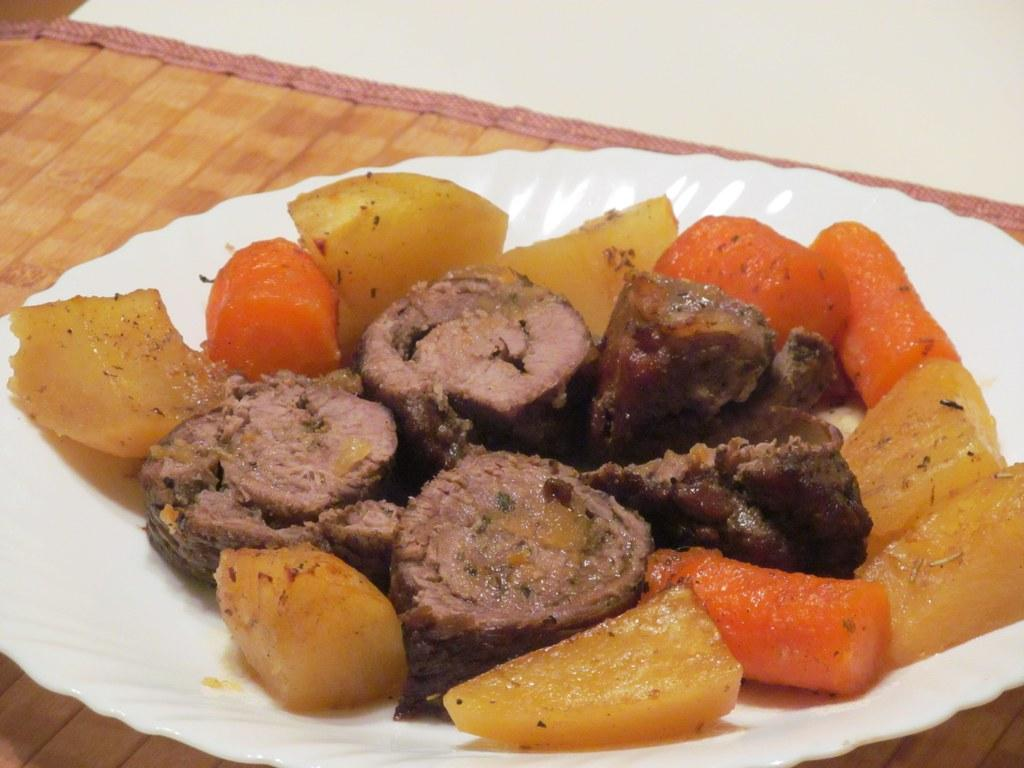What is on the plate that is visible in the image? The plate contains carrots, potatoes, and meat. What color is the table in the image? The table is brown. What is the color of the top part of the image? The top of the image is white in color. Can you see the mom feeding the pig through its throat in the image? There is no mom, pig, or any feeding activity depicted in the image. 